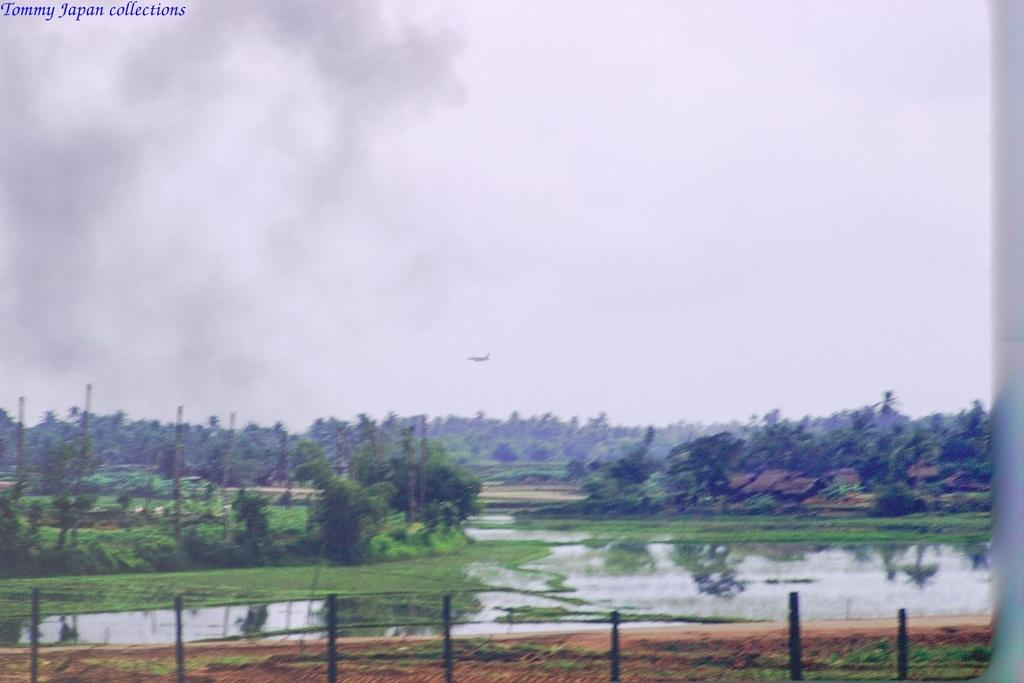What color are the poles in the image? The poles in the image are black colored. What can be seen on the ground in the image? The ground is visible in the image. What is present in the image besides the poles and ground? There is water, grass, trees, and the sky visible in the image. What is the background of the image? The sky is visible in the background of the image, and there is an object flying in the air in the background. What type of bell can be heard ringing in the image? There is no bell present in the image, and therefore no sound can be heard. What season is depicted in the image? The provided facts do not mention any specific season, so it cannot be determined from the image. 